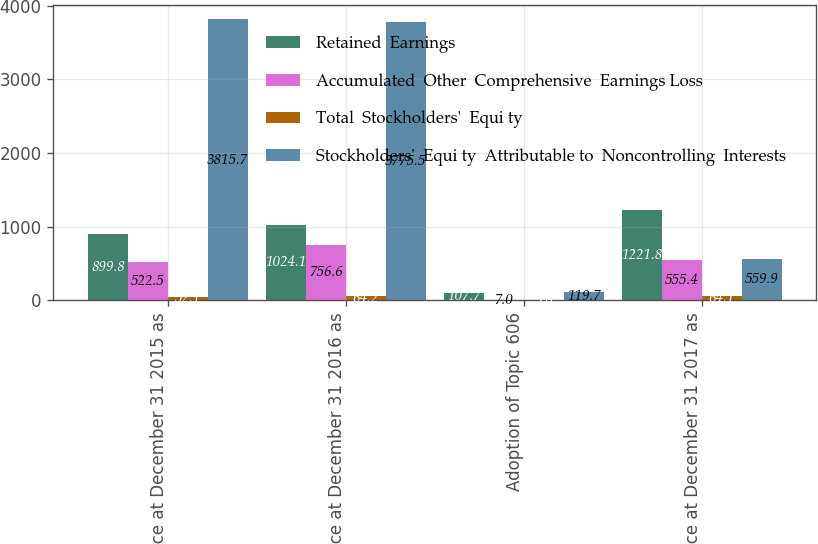<chart> <loc_0><loc_0><loc_500><loc_500><stacked_bar_chart><ecel><fcel>Balance at December 31 2015 as<fcel>Balance at December 31 2016 as<fcel>Adoption of Topic 606<fcel>Balance at December 31 2017 as<nl><fcel>Retained  Earnings<fcel>899.8<fcel>1024.1<fcel>107.7<fcel>1221.8<nl><fcel>Accumulated  Other  Comprehensive  Earnings Loss<fcel>522.5<fcel>756.6<fcel>7<fcel>555.4<nl><fcel>Total  Stockholders'  Equi ty<fcel>52.1<fcel>64.2<fcel>5<fcel>64.1<nl><fcel>Stockholders'  Equi ty  Attributable to  Noncontrolling  Interests<fcel>3815.7<fcel>3775.5<fcel>119.7<fcel>559.9<nl></chart> 